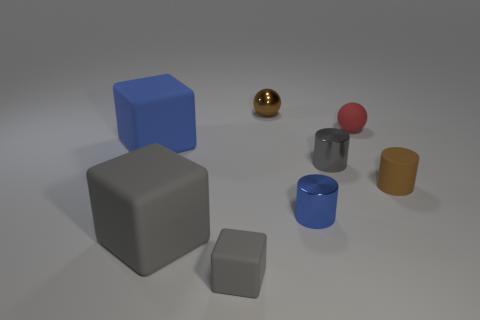Add 2 small blue matte cylinders. How many objects exist? 10 Subtract all brown spheres. How many spheres are left? 1 Subtract all gray blocks. How many blocks are left? 1 Subtract all cubes. How many objects are left? 5 Subtract all green balls. How many blue cubes are left? 1 Subtract all small cyan metal cylinders. Subtract all blue rubber blocks. How many objects are left? 7 Add 5 matte blocks. How many matte blocks are left? 8 Add 4 large things. How many large things exist? 6 Subtract 0 red cylinders. How many objects are left? 8 Subtract 1 spheres. How many spheres are left? 1 